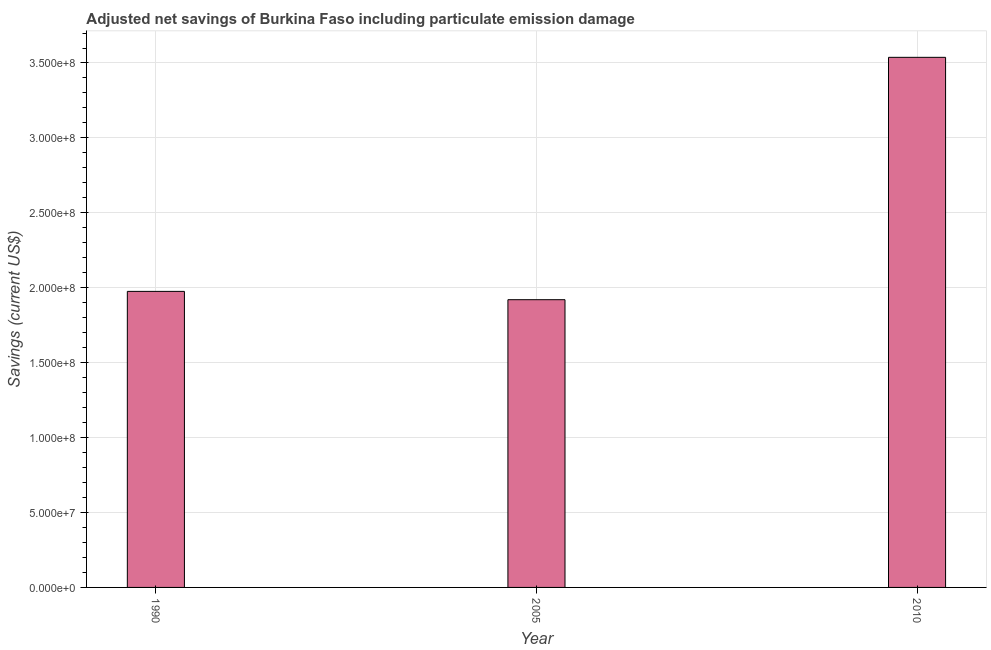Does the graph contain grids?
Provide a short and direct response. Yes. What is the title of the graph?
Make the answer very short. Adjusted net savings of Burkina Faso including particulate emission damage. What is the label or title of the Y-axis?
Your response must be concise. Savings (current US$). What is the adjusted net savings in 1990?
Your answer should be compact. 1.98e+08. Across all years, what is the maximum adjusted net savings?
Keep it short and to the point. 3.54e+08. Across all years, what is the minimum adjusted net savings?
Make the answer very short. 1.92e+08. In which year was the adjusted net savings maximum?
Make the answer very short. 2010. What is the sum of the adjusted net savings?
Offer a terse response. 7.43e+08. What is the difference between the adjusted net savings in 2005 and 2010?
Your answer should be very brief. -1.62e+08. What is the average adjusted net savings per year?
Make the answer very short. 2.48e+08. What is the median adjusted net savings?
Your answer should be compact. 1.98e+08. In how many years, is the adjusted net savings greater than 260000000 US$?
Make the answer very short. 1. Do a majority of the years between 2010 and 2005 (inclusive) have adjusted net savings greater than 120000000 US$?
Provide a succinct answer. No. What is the ratio of the adjusted net savings in 1990 to that in 2005?
Your response must be concise. 1.03. What is the difference between the highest and the second highest adjusted net savings?
Offer a terse response. 1.56e+08. What is the difference between the highest and the lowest adjusted net savings?
Make the answer very short. 1.62e+08. How many bars are there?
Ensure brevity in your answer.  3. How many years are there in the graph?
Offer a terse response. 3. What is the Savings (current US$) in 1990?
Offer a very short reply. 1.98e+08. What is the Savings (current US$) of 2005?
Offer a very short reply. 1.92e+08. What is the Savings (current US$) of 2010?
Give a very brief answer. 3.54e+08. What is the difference between the Savings (current US$) in 1990 and 2005?
Offer a very short reply. 5.55e+06. What is the difference between the Savings (current US$) in 1990 and 2010?
Make the answer very short. -1.56e+08. What is the difference between the Savings (current US$) in 2005 and 2010?
Offer a very short reply. -1.62e+08. What is the ratio of the Savings (current US$) in 1990 to that in 2010?
Make the answer very short. 0.56. What is the ratio of the Savings (current US$) in 2005 to that in 2010?
Your answer should be compact. 0.54. 